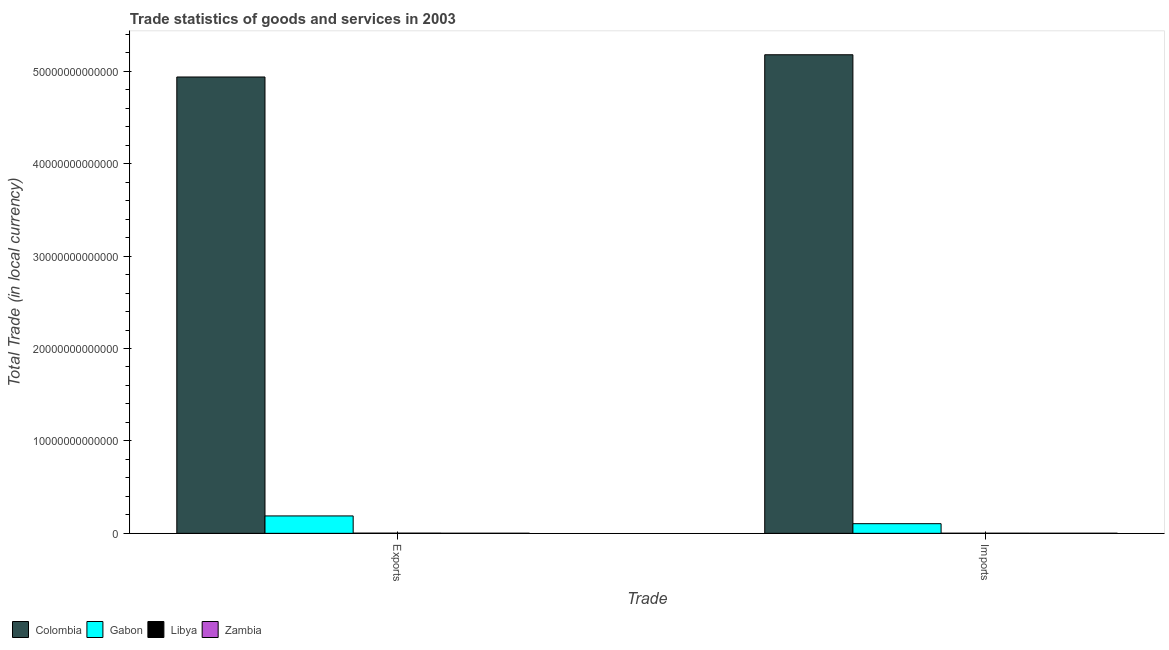How many different coloured bars are there?
Ensure brevity in your answer.  4. How many bars are there on the 2nd tick from the left?
Your answer should be compact. 4. How many bars are there on the 2nd tick from the right?
Give a very brief answer. 4. What is the label of the 2nd group of bars from the left?
Provide a short and direct response. Imports. What is the imports of goods and services in Libya?
Keep it short and to the point. 1.12e+1. Across all countries, what is the maximum export of goods and services?
Provide a short and direct response. 4.94e+13. Across all countries, what is the minimum imports of goods and services?
Ensure brevity in your answer.  9.36e+09. In which country was the imports of goods and services maximum?
Your answer should be very brief. Colombia. In which country was the export of goods and services minimum?
Provide a succinct answer. Zambia. What is the total imports of goods and services in the graph?
Your response must be concise. 5.28e+13. What is the difference between the export of goods and services in Gabon and that in Libya?
Provide a short and direct response. 1.86e+12. What is the difference between the export of goods and services in Colombia and the imports of goods and services in Gabon?
Ensure brevity in your answer.  4.83e+13. What is the average imports of goods and services per country?
Your response must be concise. 1.32e+13. What is the difference between the imports of goods and services and export of goods and services in Libya?
Offer a very short reply. -8.08e+09. What is the ratio of the export of goods and services in Gabon to that in Colombia?
Give a very brief answer. 0.04. Is the export of goods and services in Zambia less than that in Gabon?
Make the answer very short. Yes. What does the 3rd bar from the left in Imports represents?
Keep it short and to the point. Libya. What does the 3rd bar from the right in Exports represents?
Make the answer very short. Gabon. How many bars are there?
Offer a terse response. 8. What is the difference between two consecutive major ticks on the Y-axis?
Provide a short and direct response. 1.00e+13. How many legend labels are there?
Ensure brevity in your answer.  4. What is the title of the graph?
Your response must be concise. Trade statistics of goods and services in 2003. What is the label or title of the X-axis?
Offer a terse response. Trade. What is the label or title of the Y-axis?
Provide a succinct answer. Total Trade (in local currency). What is the Total Trade (in local currency) of Colombia in Exports?
Offer a very short reply. 4.94e+13. What is the Total Trade (in local currency) in Gabon in Exports?
Give a very brief answer. 1.88e+12. What is the Total Trade (in local currency) of Libya in Exports?
Provide a succinct answer. 1.93e+1. What is the Total Trade (in local currency) of Zambia in Exports?
Offer a very short reply. 7.51e+09. What is the Total Trade (in local currency) in Colombia in Imports?
Provide a succinct answer. 5.18e+13. What is the Total Trade (in local currency) in Gabon in Imports?
Provide a succinct answer. 1.04e+12. What is the Total Trade (in local currency) in Libya in Imports?
Your answer should be very brief. 1.12e+1. What is the Total Trade (in local currency) of Zambia in Imports?
Your answer should be compact. 9.36e+09. Across all Trade, what is the maximum Total Trade (in local currency) of Colombia?
Offer a terse response. 5.18e+13. Across all Trade, what is the maximum Total Trade (in local currency) in Gabon?
Your answer should be compact. 1.88e+12. Across all Trade, what is the maximum Total Trade (in local currency) of Libya?
Make the answer very short. 1.93e+1. Across all Trade, what is the maximum Total Trade (in local currency) of Zambia?
Keep it short and to the point. 9.36e+09. Across all Trade, what is the minimum Total Trade (in local currency) in Colombia?
Keep it short and to the point. 4.94e+13. Across all Trade, what is the minimum Total Trade (in local currency) in Gabon?
Offer a terse response. 1.04e+12. Across all Trade, what is the minimum Total Trade (in local currency) in Libya?
Offer a terse response. 1.12e+1. Across all Trade, what is the minimum Total Trade (in local currency) of Zambia?
Your response must be concise. 7.51e+09. What is the total Total Trade (in local currency) of Colombia in the graph?
Give a very brief answer. 1.01e+14. What is the total Total Trade (in local currency) of Gabon in the graph?
Your answer should be compact. 2.93e+12. What is the total Total Trade (in local currency) in Libya in the graph?
Offer a very short reply. 3.05e+1. What is the total Total Trade (in local currency) in Zambia in the graph?
Keep it short and to the point. 1.69e+1. What is the difference between the Total Trade (in local currency) of Colombia in Exports and that in Imports?
Provide a succinct answer. -2.41e+12. What is the difference between the Total Trade (in local currency) in Gabon in Exports and that in Imports?
Offer a very short reply. 8.39e+11. What is the difference between the Total Trade (in local currency) in Libya in Exports and that in Imports?
Keep it short and to the point. 8.08e+09. What is the difference between the Total Trade (in local currency) of Zambia in Exports and that in Imports?
Ensure brevity in your answer.  -1.85e+09. What is the difference between the Total Trade (in local currency) in Colombia in Exports and the Total Trade (in local currency) in Gabon in Imports?
Provide a short and direct response. 4.83e+13. What is the difference between the Total Trade (in local currency) in Colombia in Exports and the Total Trade (in local currency) in Libya in Imports?
Your answer should be compact. 4.94e+13. What is the difference between the Total Trade (in local currency) in Colombia in Exports and the Total Trade (in local currency) in Zambia in Imports?
Your answer should be compact. 4.94e+13. What is the difference between the Total Trade (in local currency) in Gabon in Exports and the Total Trade (in local currency) in Libya in Imports?
Give a very brief answer. 1.87e+12. What is the difference between the Total Trade (in local currency) of Gabon in Exports and the Total Trade (in local currency) of Zambia in Imports?
Your response must be concise. 1.87e+12. What is the difference between the Total Trade (in local currency) in Libya in Exports and the Total Trade (in local currency) in Zambia in Imports?
Give a very brief answer. 9.91e+09. What is the average Total Trade (in local currency) of Colombia per Trade?
Provide a short and direct response. 5.06e+13. What is the average Total Trade (in local currency) in Gabon per Trade?
Ensure brevity in your answer.  1.46e+12. What is the average Total Trade (in local currency) of Libya per Trade?
Give a very brief answer. 1.52e+1. What is the average Total Trade (in local currency) of Zambia per Trade?
Your response must be concise. 8.44e+09. What is the difference between the Total Trade (in local currency) in Colombia and Total Trade (in local currency) in Gabon in Exports?
Offer a very short reply. 4.75e+13. What is the difference between the Total Trade (in local currency) in Colombia and Total Trade (in local currency) in Libya in Exports?
Offer a very short reply. 4.94e+13. What is the difference between the Total Trade (in local currency) of Colombia and Total Trade (in local currency) of Zambia in Exports?
Provide a succinct answer. 4.94e+13. What is the difference between the Total Trade (in local currency) in Gabon and Total Trade (in local currency) in Libya in Exports?
Offer a terse response. 1.86e+12. What is the difference between the Total Trade (in local currency) of Gabon and Total Trade (in local currency) of Zambia in Exports?
Offer a very short reply. 1.88e+12. What is the difference between the Total Trade (in local currency) in Libya and Total Trade (in local currency) in Zambia in Exports?
Keep it short and to the point. 1.18e+1. What is the difference between the Total Trade (in local currency) in Colombia and Total Trade (in local currency) in Gabon in Imports?
Provide a succinct answer. 5.07e+13. What is the difference between the Total Trade (in local currency) of Colombia and Total Trade (in local currency) of Libya in Imports?
Provide a short and direct response. 5.18e+13. What is the difference between the Total Trade (in local currency) in Colombia and Total Trade (in local currency) in Zambia in Imports?
Your answer should be very brief. 5.18e+13. What is the difference between the Total Trade (in local currency) of Gabon and Total Trade (in local currency) of Libya in Imports?
Provide a succinct answer. 1.03e+12. What is the difference between the Total Trade (in local currency) in Gabon and Total Trade (in local currency) in Zambia in Imports?
Your answer should be very brief. 1.03e+12. What is the difference between the Total Trade (in local currency) in Libya and Total Trade (in local currency) in Zambia in Imports?
Your answer should be compact. 1.83e+09. What is the ratio of the Total Trade (in local currency) in Colombia in Exports to that in Imports?
Your response must be concise. 0.95. What is the ratio of the Total Trade (in local currency) of Gabon in Exports to that in Imports?
Give a very brief answer. 1.8. What is the ratio of the Total Trade (in local currency) of Libya in Exports to that in Imports?
Provide a succinct answer. 1.72. What is the ratio of the Total Trade (in local currency) in Zambia in Exports to that in Imports?
Your response must be concise. 0.8. What is the difference between the highest and the second highest Total Trade (in local currency) of Colombia?
Give a very brief answer. 2.41e+12. What is the difference between the highest and the second highest Total Trade (in local currency) of Gabon?
Your response must be concise. 8.39e+11. What is the difference between the highest and the second highest Total Trade (in local currency) of Libya?
Your answer should be compact. 8.08e+09. What is the difference between the highest and the second highest Total Trade (in local currency) of Zambia?
Offer a very short reply. 1.85e+09. What is the difference between the highest and the lowest Total Trade (in local currency) of Colombia?
Give a very brief answer. 2.41e+12. What is the difference between the highest and the lowest Total Trade (in local currency) in Gabon?
Keep it short and to the point. 8.39e+11. What is the difference between the highest and the lowest Total Trade (in local currency) of Libya?
Your response must be concise. 8.08e+09. What is the difference between the highest and the lowest Total Trade (in local currency) of Zambia?
Offer a very short reply. 1.85e+09. 